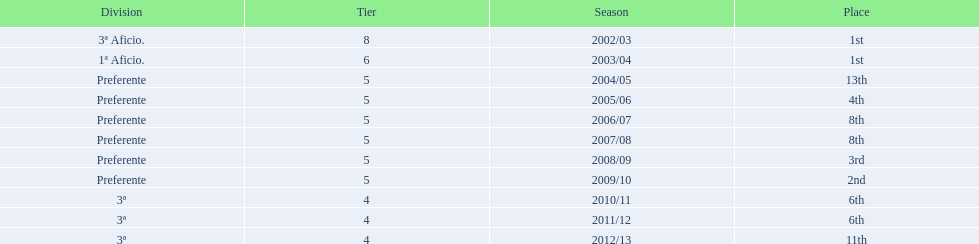Which seasons were played in tier four? 2010/11, 2011/12, 2012/13. Of these seasons, which resulted in 6th place? 2010/11, 2011/12. Which of the remaining happened last? 2011/12. 